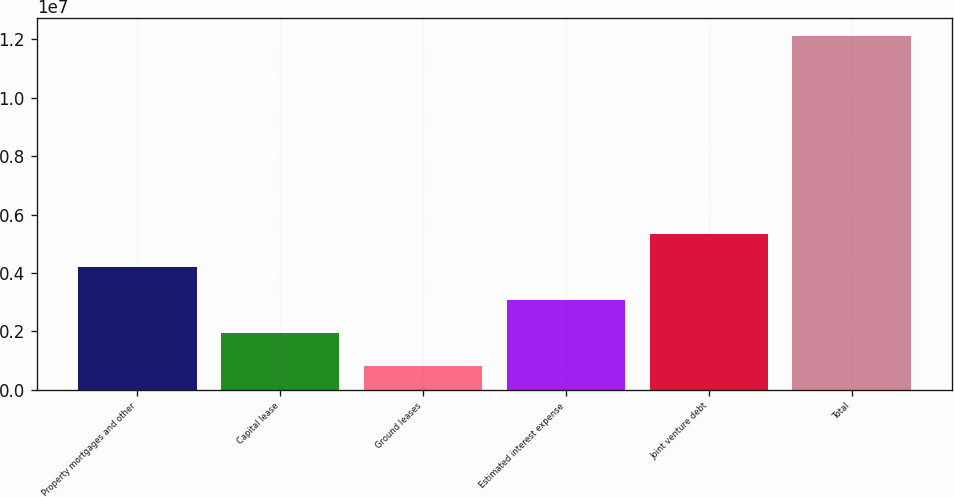Convert chart. <chart><loc_0><loc_0><loc_500><loc_500><bar_chart><fcel>Property mortgages and other<fcel>Capital lease<fcel>Ground leases<fcel>Estimated interest expense<fcel>Joint venture debt<fcel>Total<nl><fcel>4.2139e+06<fcel>1.95587e+06<fcel>826858<fcel>3.08488e+06<fcel>5.34291e+06<fcel>1.2117e+07<nl></chart> 